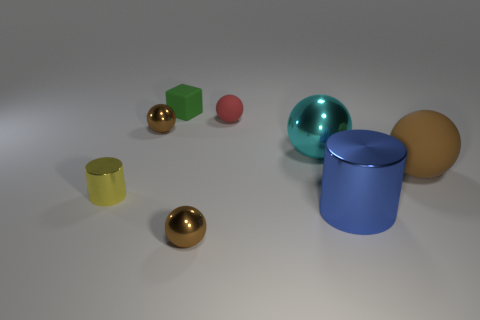Subtract all small spheres. How many spheres are left? 2 Subtract all small yellow metallic objects. Subtract all small spheres. How many objects are left? 4 Add 8 small yellow objects. How many small yellow objects are left? 9 Add 6 small rubber objects. How many small rubber objects exist? 8 Add 2 small matte spheres. How many objects exist? 10 Subtract all cyan spheres. How many spheres are left? 4 Subtract 0 yellow blocks. How many objects are left? 8 Subtract all blocks. How many objects are left? 7 Subtract 3 balls. How many balls are left? 2 Subtract all cyan balls. Subtract all brown cylinders. How many balls are left? 4 